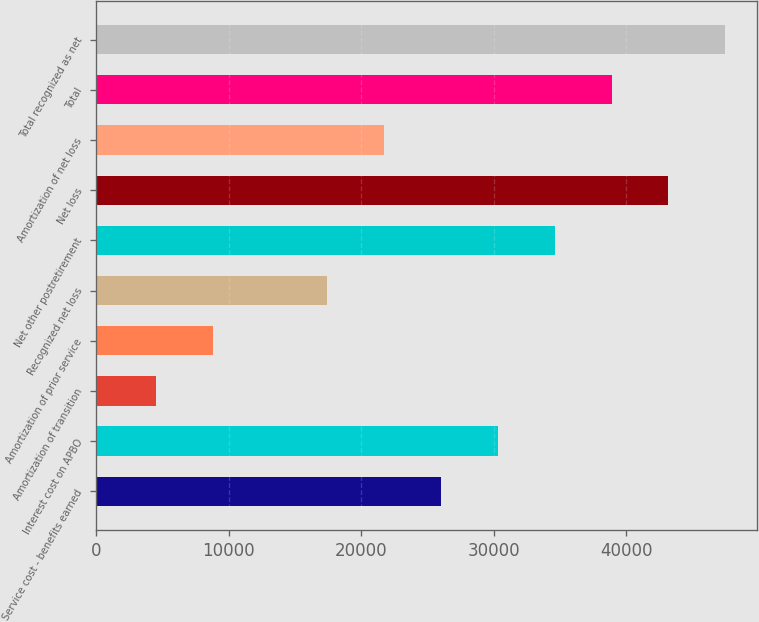Convert chart. <chart><loc_0><loc_0><loc_500><loc_500><bar_chart><fcel>Service cost - benefits earned<fcel>Interest cost on APBO<fcel>Amortization of transition<fcel>Amortization of prior service<fcel>Recognized net loss<fcel>Net other postretirement<fcel>Net loss<fcel>Amortization of net loss<fcel>Total<fcel>Total recognized as net<nl><fcel>26001.4<fcel>30295.3<fcel>4531.9<fcel>8825.8<fcel>17413.6<fcel>34589.2<fcel>43177<fcel>21707.5<fcel>38883.1<fcel>47470.9<nl></chart> 